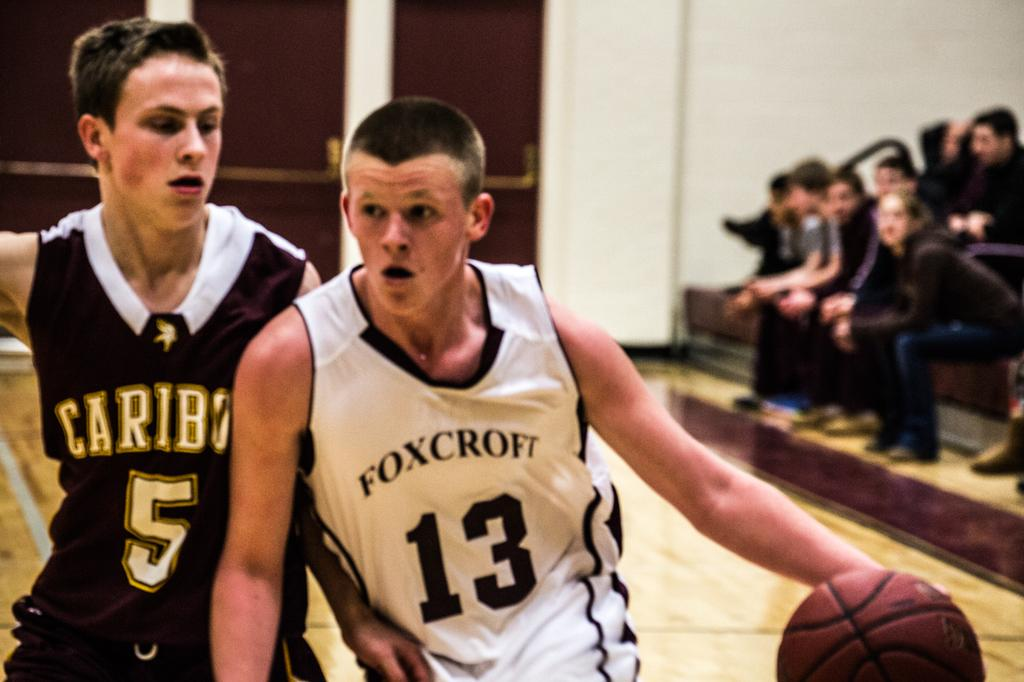Provide a one-sentence caption for the provided image. A basketball game and the player with the ball has a jersey on that says Foxcroft 13. 